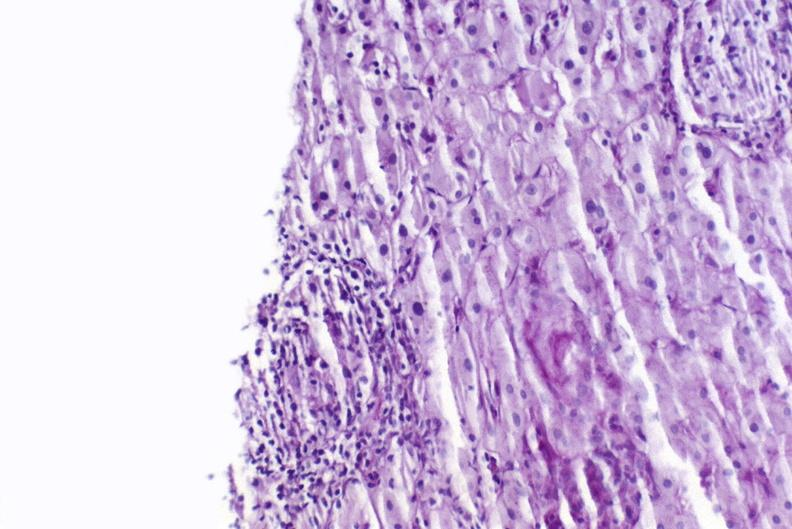s granulosa cell tumor present?
Answer the question using a single word or phrase. No 